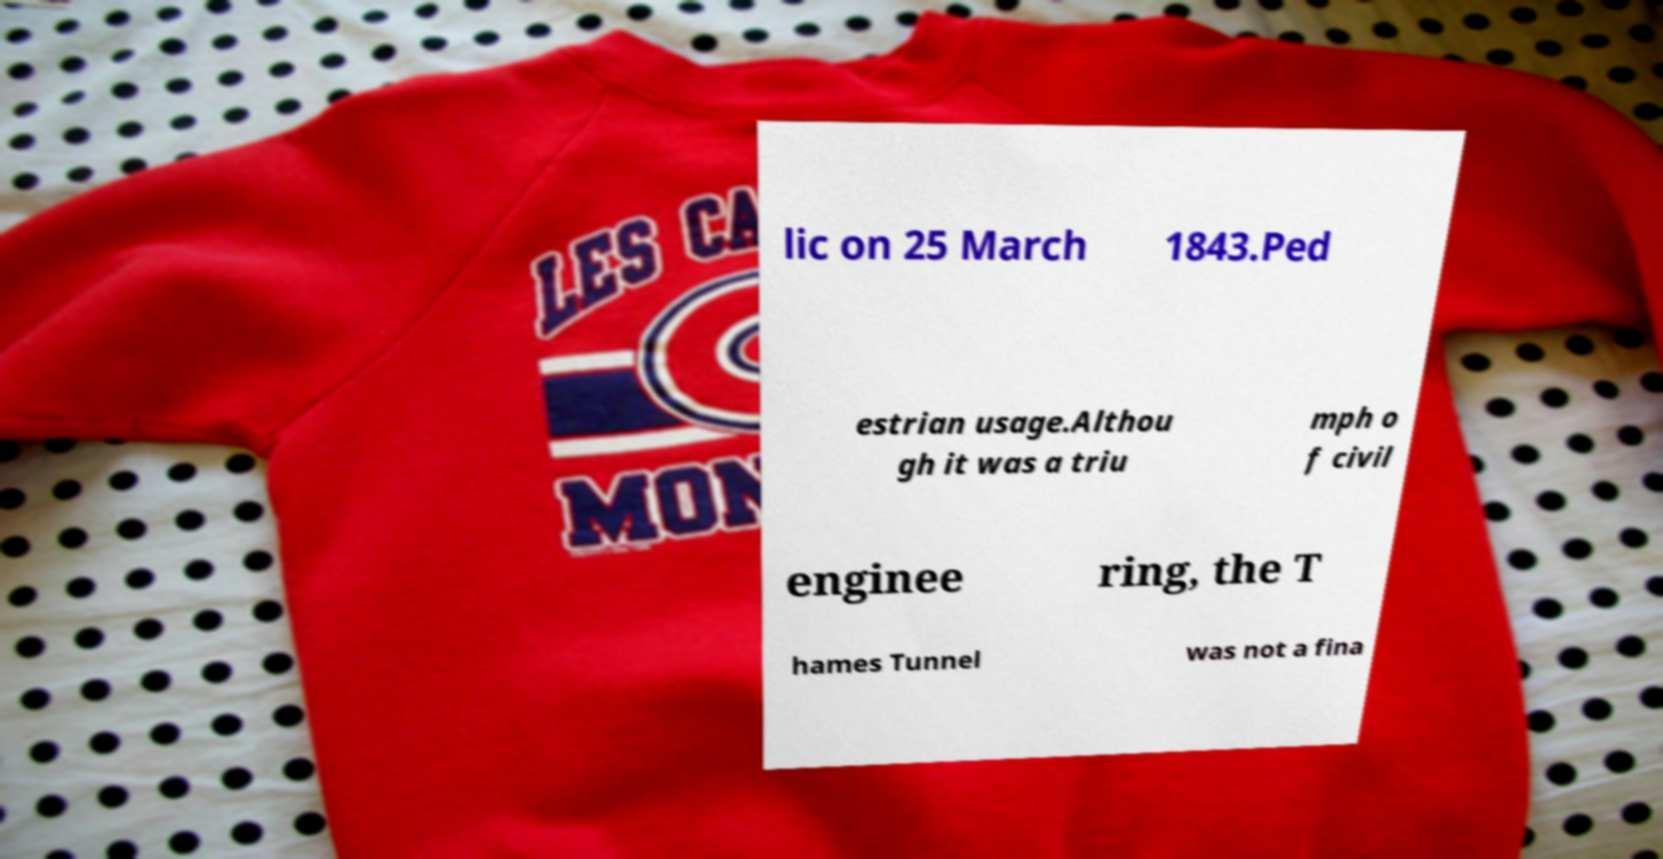Can you accurately transcribe the text from the provided image for me? lic on 25 March 1843.Ped estrian usage.Althou gh it was a triu mph o f civil enginee ring, the T hames Tunnel was not a fina 